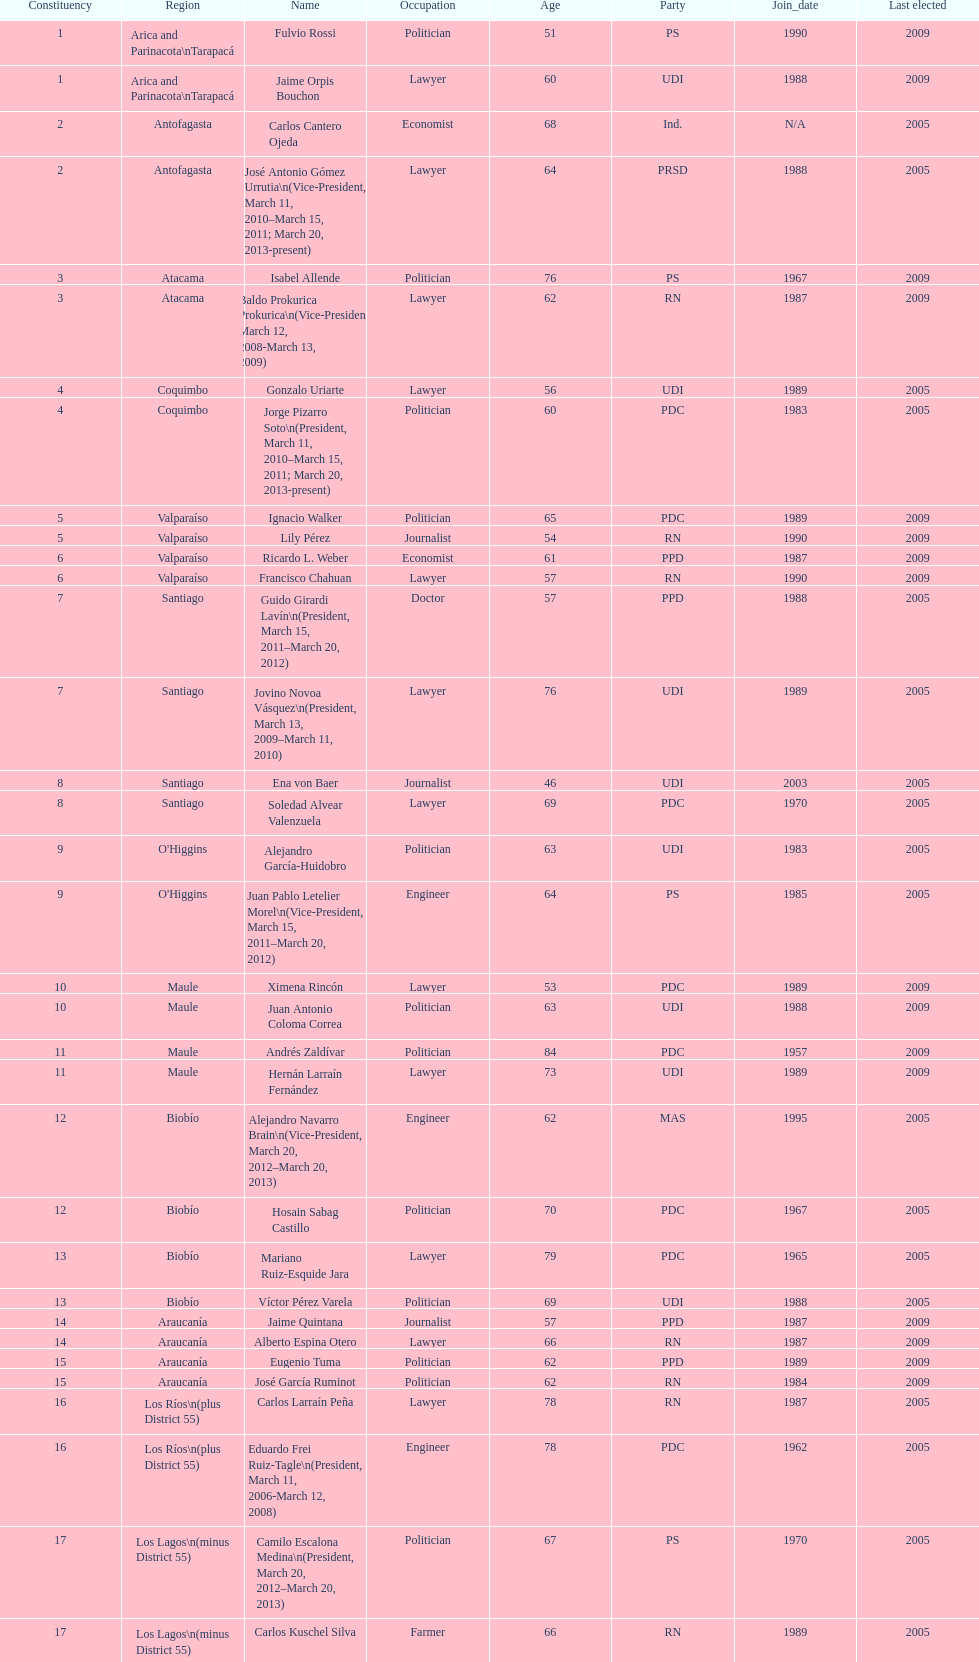How many total consituency are listed in the table? 19. 